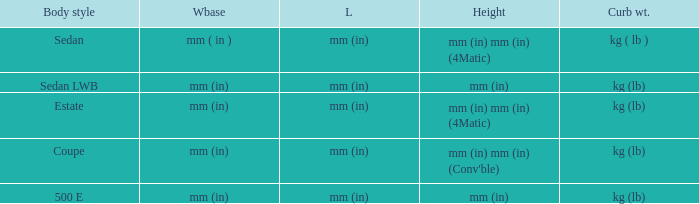What's the length of the model with Sedan body style? Mm (in). 